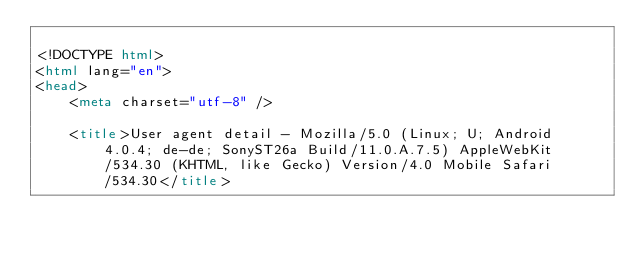Convert code to text. <code><loc_0><loc_0><loc_500><loc_500><_HTML_>
<!DOCTYPE html>
<html lang="en">
<head>
    <meta charset="utf-8" />
            
    <title>User agent detail - Mozilla/5.0 (Linux; U; Android 4.0.4; de-de; SonyST26a Build/11.0.A.7.5) AppleWebKit/534.30 (KHTML, like Gecko) Version/4.0 Mobile Safari/534.30</title>
        </code> 